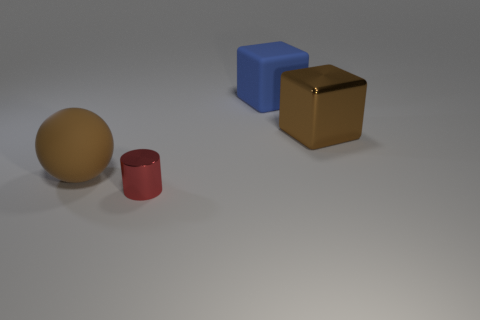Add 2 green metallic spheres. How many objects exist? 6 Subtract all cylinders. How many objects are left? 3 Add 4 rubber objects. How many rubber objects are left? 6 Add 2 tiny green rubber blocks. How many tiny green rubber blocks exist? 2 Subtract 0 blue cylinders. How many objects are left? 4 Subtract all matte cubes. Subtract all big rubber spheres. How many objects are left? 2 